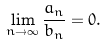<formula> <loc_0><loc_0><loc_500><loc_500>\lim _ { n \rightarrow \infty } \frac { a _ { n } } { b _ { n } } = 0 .</formula> 